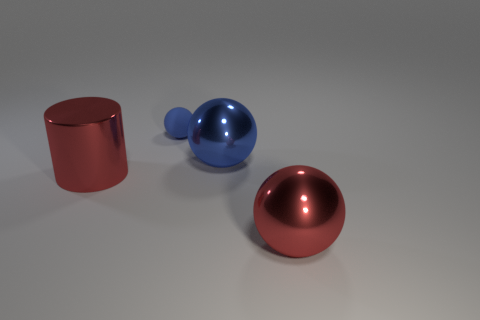Add 3 large brown objects. How many objects exist? 7 Subtract all spheres. How many objects are left? 1 Subtract 0 gray cylinders. How many objects are left? 4 Subtract all large green rubber spheres. Subtract all blue rubber spheres. How many objects are left? 3 Add 3 large metallic spheres. How many large metallic spheres are left? 5 Add 4 purple rubber cubes. How many purple rubber cubes exist? 4 